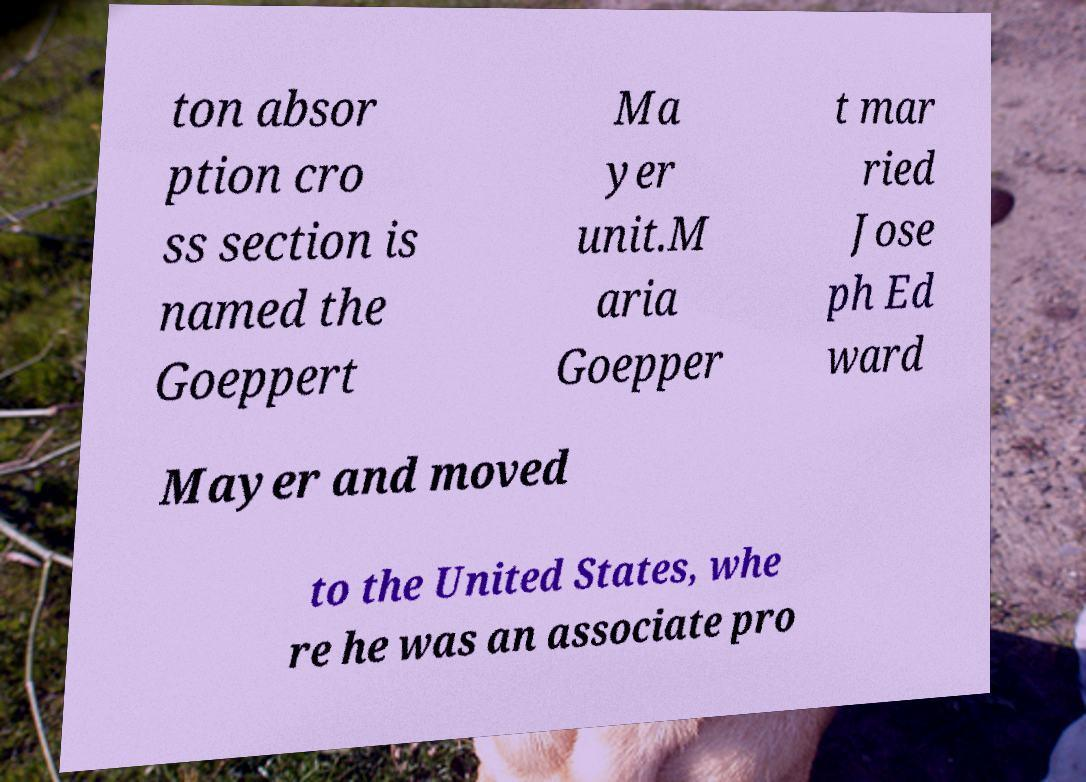Please identify and transcribe the text found in this image. ton absor ption cro ss section is named the Goeppert Ma yer unit.M aria Goepper t mar ried Jose ph Ed ward Mayer and moved to the United States, whe re he was an associate pro 